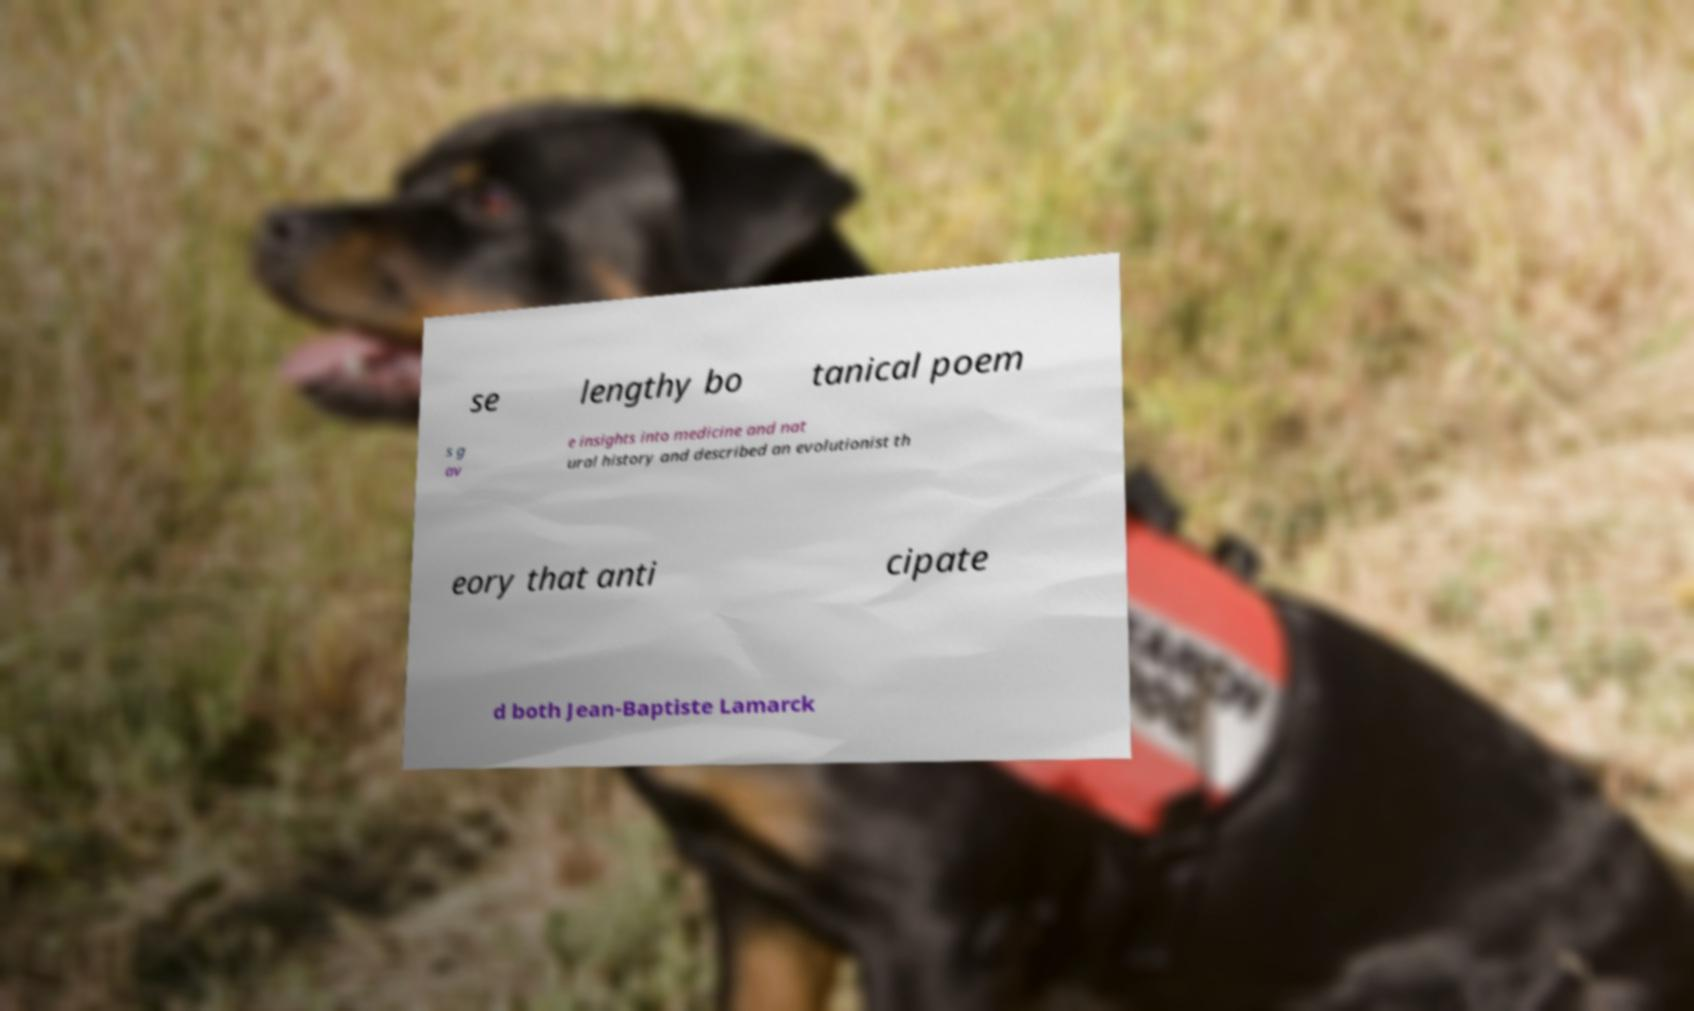I need the written content from this picture converted into text. Can you do that? se lengthy bo tanical poem s g av e insights into medicine and nat ural history and described an evolutionist th eory that anti cipate d both Jean-Baptiste Lamarck 